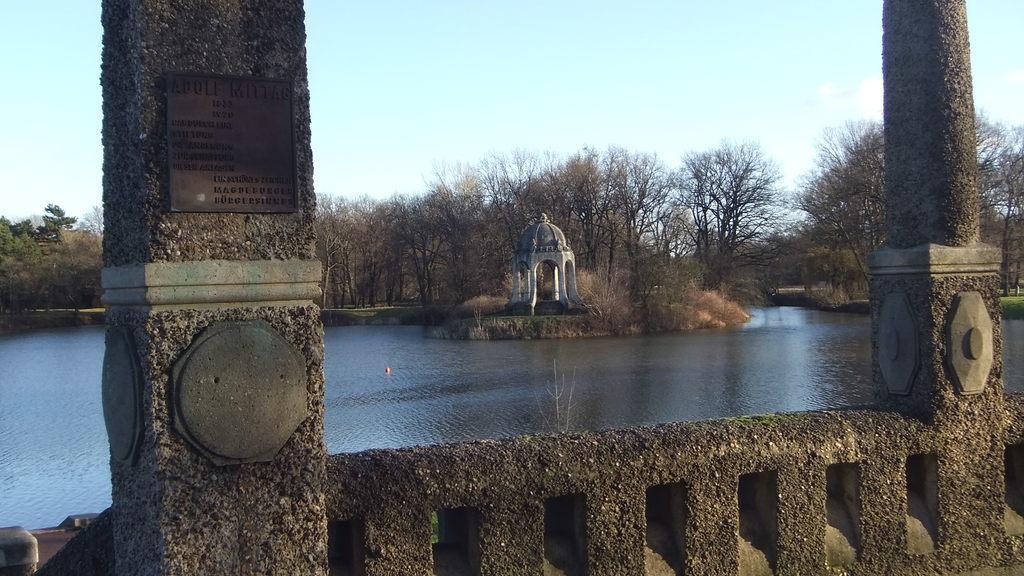Describe this image in one or two sentences. In this picture there are two pillars on the right and left side of the image and there is water in the center of the image and there are trees in the background area of the image. 